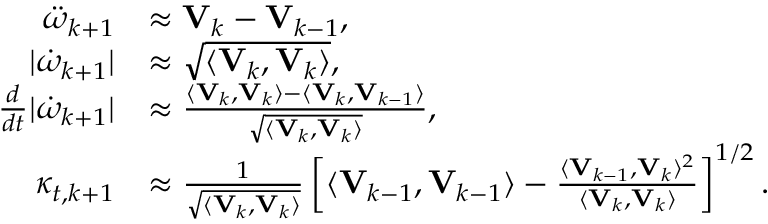<formula> <loc_0><loc_0><loc_500><loc_500>\begin{array} { r l } { \ddot { \omega } _ { k + 1 } } & { \approx V _ { k } - V _ { k - 1 } , } \\ { | \dot { \omega } _ { k + 1 } | } & { \approx \sqrt { \langle V _ { k } , V _ { k } \rangle } , } \\ { \frac { d } { d t } | \dot { \omega } _ { k + 1 } | } & { \approx \frac { \langle V _ { k } , V _ { k } \rangle - \langle V _ { k } , V _ { k - 1 } \rangle } { \sqrt { \langle V _ { k } , V _ { k } \rangle } } , } \\ { \kappa _ { t , k + 1 } } & { \approx \frac { 1 } { \sqrt { \langle V _ { k } , V _ { k } \rangle } } \left [ \langle V _ { k - 1 } , V _ { k - 1 } \rangle - \frac { \langle V _ { k - 1 } , V _ { k } \rangle ^ { 2 } } { \langle V _ { k } , V _ { k } \rangle } \right ] ^ { 1 / 2 } . } \end{array}</formula> 